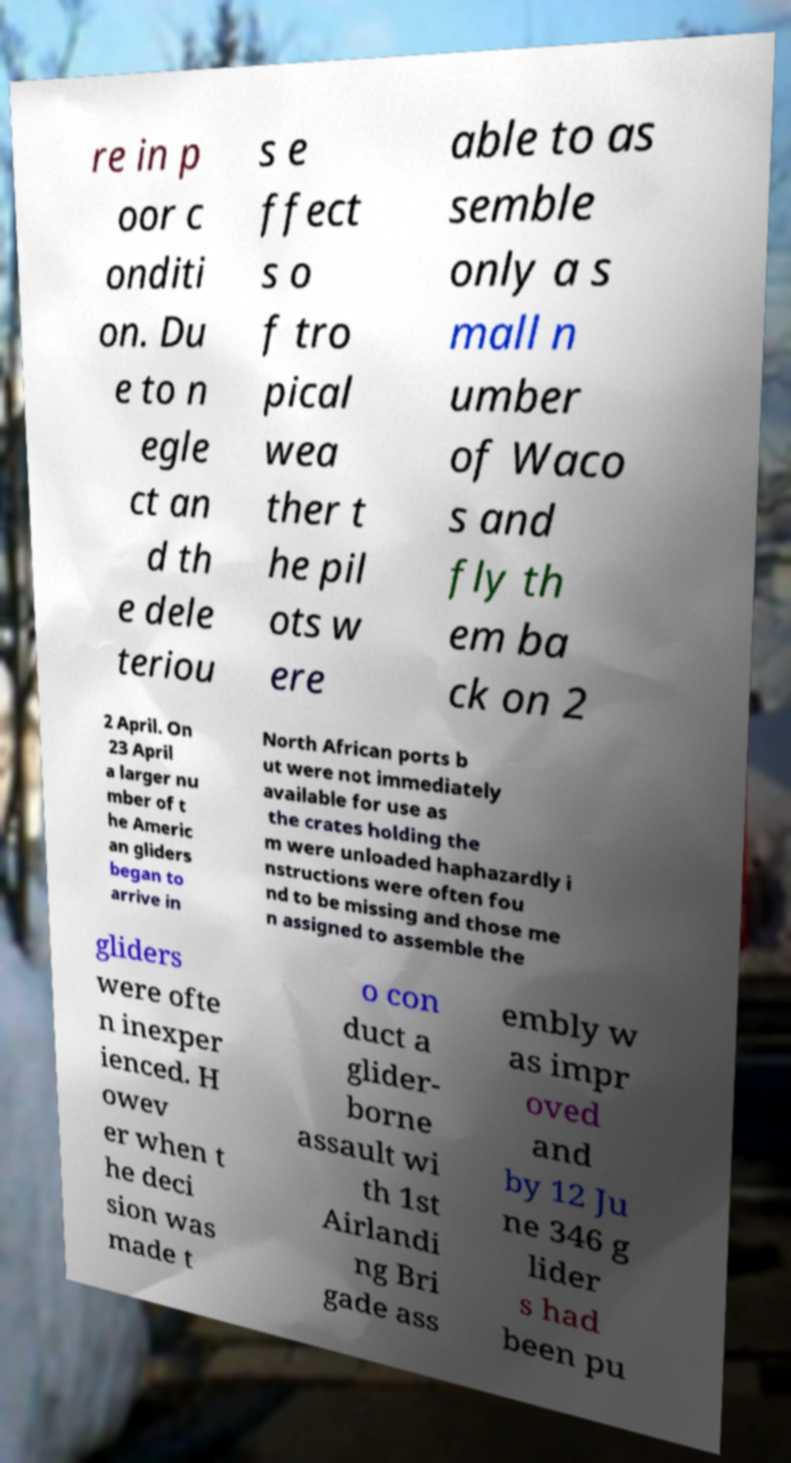Could you assist in decoding the text presented in this image and type it out clearly? re in p oor c onditi on. Du e to n egle ct an d th e dele teriou s e ffect s o f tro pical wea ther t he pil ots w ere able to as semble only a s mall n umber of Waco s and fly th em ba ck on 2 2 April. On 23 April a larger nu mber of t he Americ an gliders began to arrive in North African ports b ut were not immediately available for use as the crates holding the m were unloaded haphazardly i nstructions were often fou nd to be missing and those me n assigned to assemble the gliders were ofte n inexper ienced. H owev er when t he deci sion was made t o con duct a glider- borne assault wi th 1st Airlandi ng Bri gade ass embly w as impr oved and by 12 Ju ne 346 g lider s had been pu 